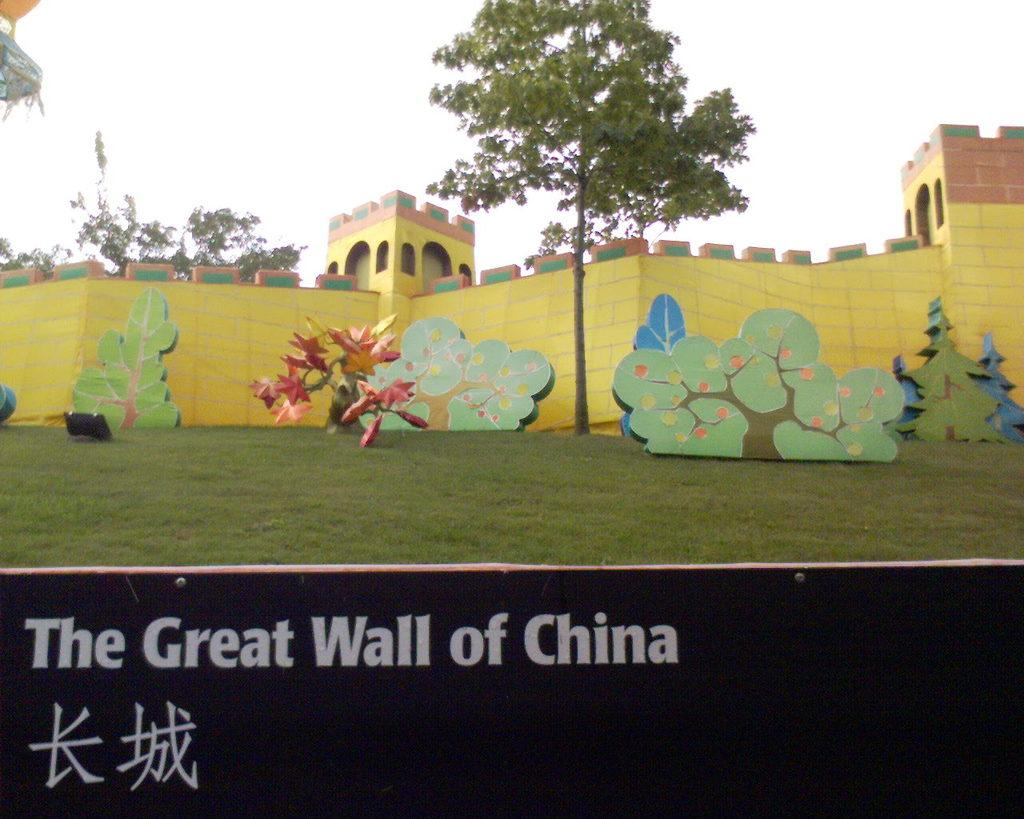What is the main structure in the image? There is an artificial china wall in the image. Are there any plants near the china wall? Yes, there is a tree near the china wall. What can be seen in the background of the image? There is a tree and the sky visible in the background of the image. What type of mint can be seen growing near the china wall in the image? There is no mint visible in the image; it only features an artificial china wall, a tree near it, and a tree and the sky in the background. 